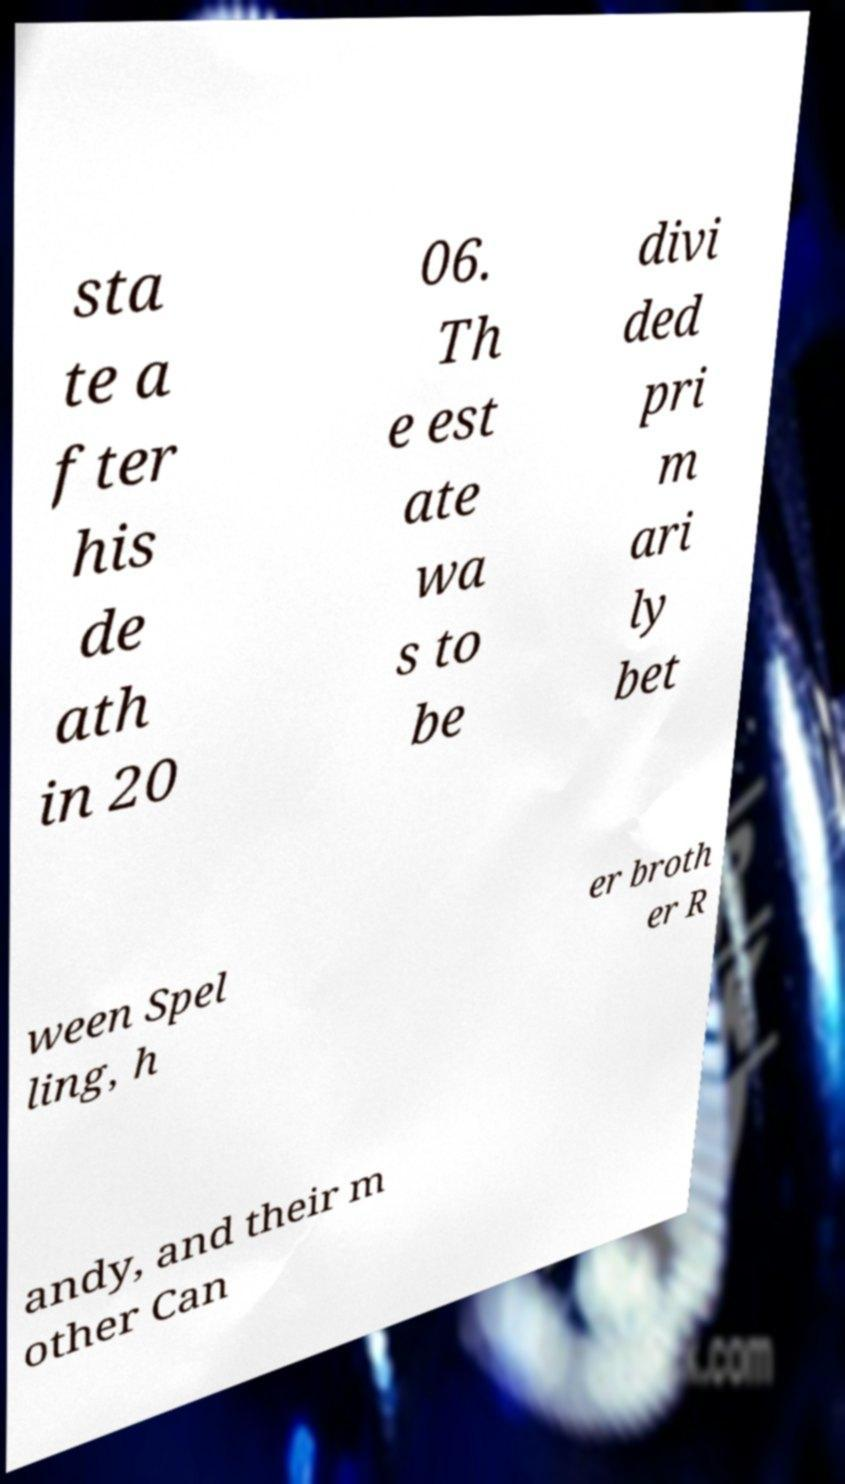There's text embedded in this image that I need extracted. Can you transcribe it verbatim? sta te a fter his de ath in 20 06. Th e est ate wa s to be divi ded pri m ari ly bet ween Spel ling, h er broth er R andy, and their m other Can 